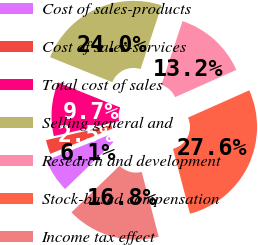Convert chart. <chart><loc_0><loc_0><loc_500><loc_500><pie_chart><fcel>Cost of sales-products<fcel>Cost of sales-services<fcel>Total cost of sales<fcel>Selling general and<fcel>Research and development<fcel>Stock-based compensation<fcel>Income tax effect<nl><fcel>6.11%<fcel>2.55%<fcel>9.68%<fcel>24.01%<fcel>13.25%<fcel>27.58%<fcel>16.82%<nl></chart> 